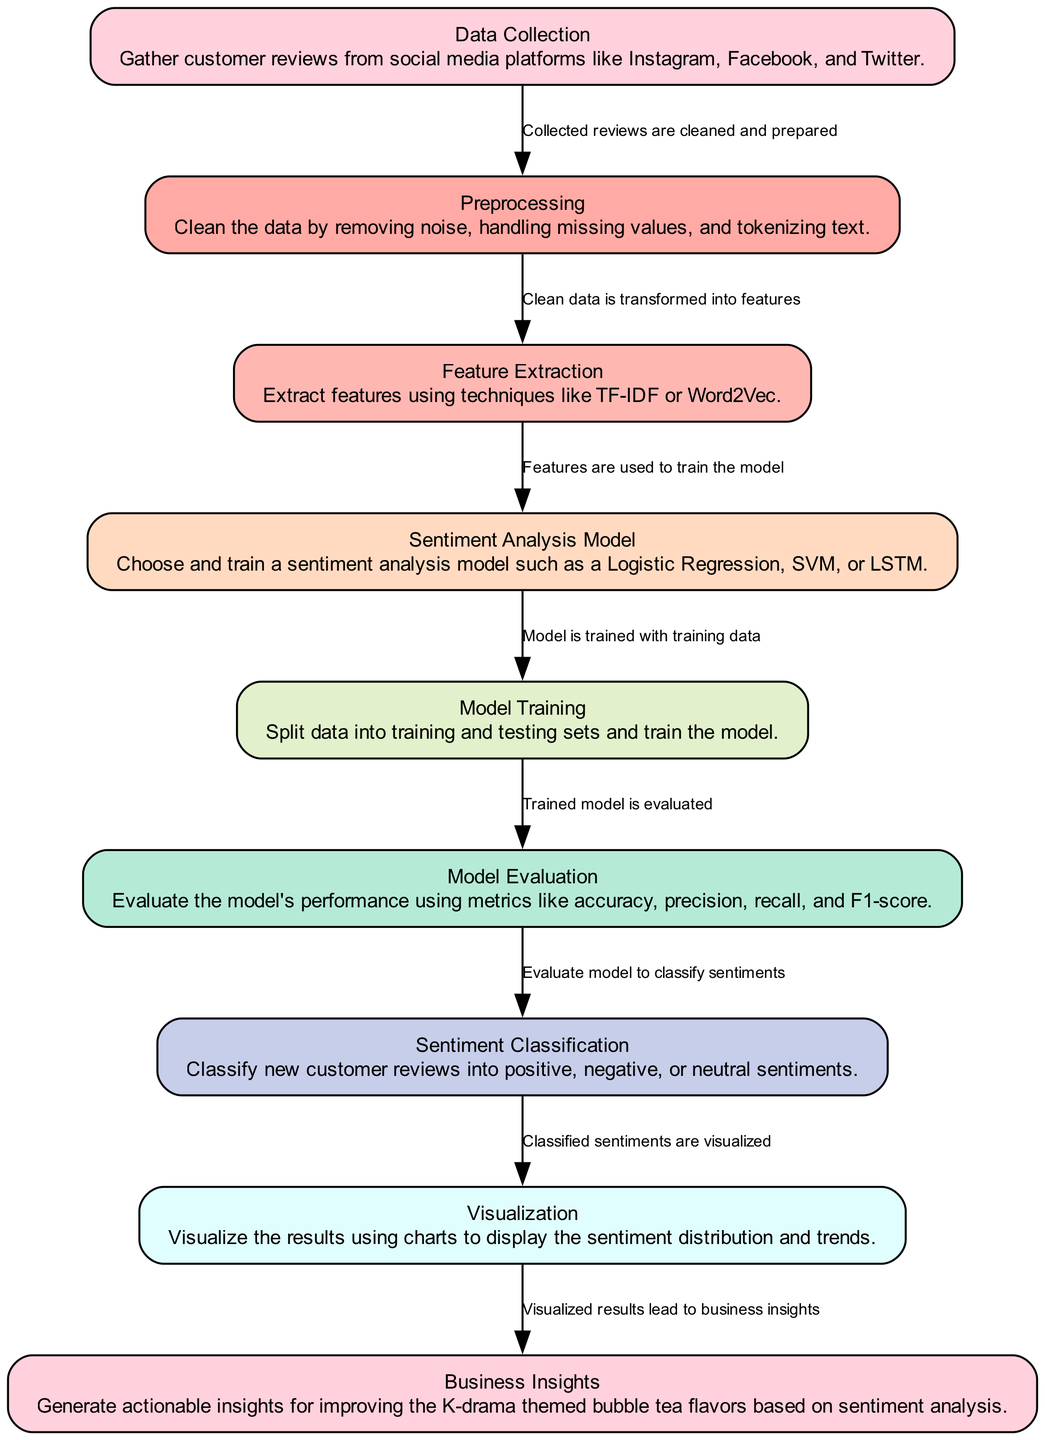What is the first step in the sentiment analysis process? The diagram shows that the first node is "Data Collection," which is where customer reviews are gathered from social media platforms.
Answer: Data Collection How many nodes are present in the diagram? By counting all nodes displayed in the diagram, we find that there are a total of 9 distinct nodes.
Answer: 9 What connects data collection to preprocessing? The diagram illustrates a directed edge labeled "Collected reviews are cleaned and prepared," which signifies the connection between these two steps.
Answer: Collected reviews are cleaned and prepared Which model can be used for sentiment analysis in this pipeline? The diagram presents "Logistic Regression," "SVM," and "LSTM" as options under the "Sentiment Analysis Model" node, indicating these choices for modeling.
Answer: Logistic Regression, SVM, LSTM What is evaluated in the model evaluation step? The "Model Evaluation" node is focused on assessing the trained model's performance using metrics such as accuracy, precision, recall, and F1-score as described.
Answer: Model performance metrics Which node follows sentiment classification? According to the diagram’s flow, the node that follows "Sentiment Classification" is "Visualization," signifying that visual representations of classified sentiments come next.
Answer: Visualization What is the output of the visualization process? The "Visualization" node leads to the generation of "Business Insights," indicating that the output of visualizing results is insights for business decisions.
Answer: Business Insights How does feature extraction relate to preprocessing? The edge labeled "Clean data is transformed into features" indicates that feature extraction follows preprocessing, suggesting a direct relationship where features are derived from preprocessed data.
Answer: Clean data is transformed into features In total, how many edges are shown in the diagram? By counting the connecting lines between nodes, the diagram exhibits a total of 8 edges that represent the flow of processes in the sentiment analysis pipeline.
Answer: 8 